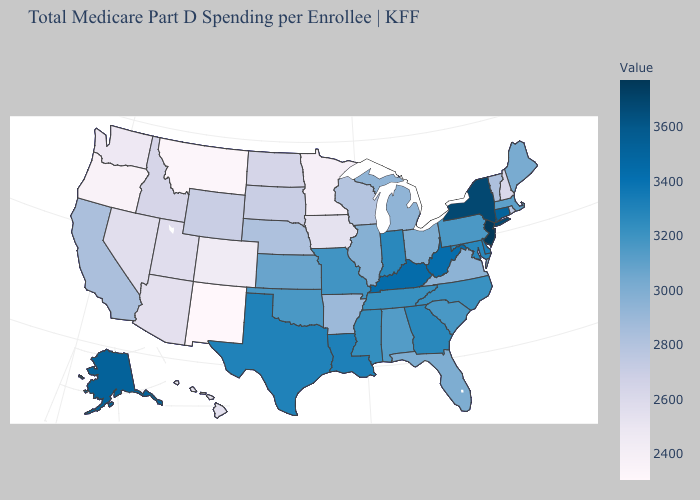Among the states that border Minnesota , does Wisconsin have the highest value?
Answer briefly. Yes. Among the states that border New York , does Connecticut have the highest value?
Answer briefly. No. Among the states that border North Carolina , which have the lowest value?
Give a very brief answer. Virginia. Is the legend a continuous bar?
Concise answer only. Yes. Does Oklahoma have the lowest value in the South?
Write a very short answer. No. 